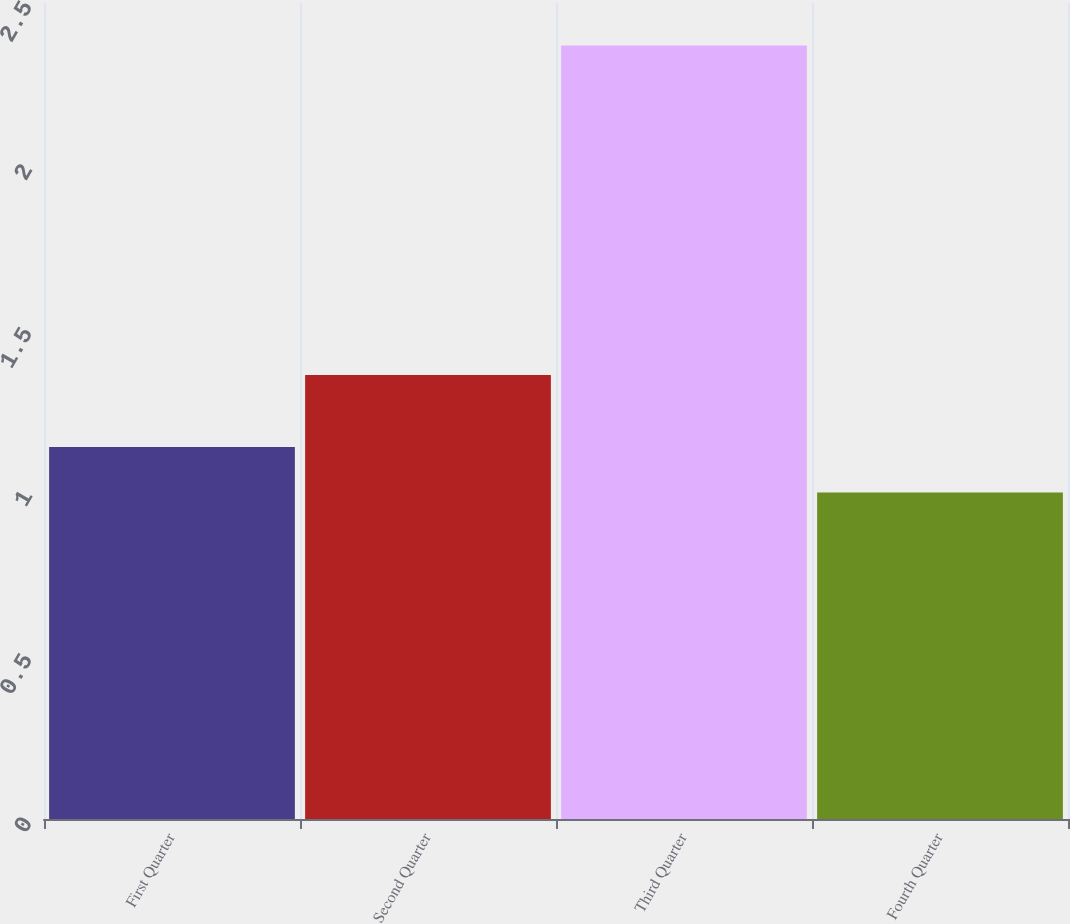Convert chart to OTSL. <chart><loc_0><loc_0><loc_500><loc_500><bar_chart><fcel>First Quarter<fcel>Second Quarter<fcel>Third Quarter<fcel>Fourth Quarter<nl><fcel>1.14<fcel>1.36<fcel>2.37<fcel>1<nl></chart> 